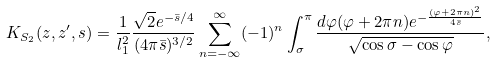<formula> <loc_0><loc_0><loc_500><loc_500>K _ { S _ { 2 } } ( z , z ^ { \prime } , s ) = { \frac { 1 } { l _ { 1 } ^ { 2 } } } { \frac { \sqrt { 2 } e ^ { - { \bar { s } / 4 } } } { ( 4 \pi \bar { s } ) ^ { 3 / 2 } } } \sum _ { n = - \infty } ^ { \infty } ( - 1 ) ^ { n } \int _ { \sigma } ^ { \pi } { \frac { d \varphi ( \varphi + 2 \pi n ) e ^ { - { \frac { ( \varphi + 2 \pi n ) ^ { 2 } } { 4 \bar { s } } } } } { \sqrt { \cos \sigma - \cos \varphi } } } ,</formula> 